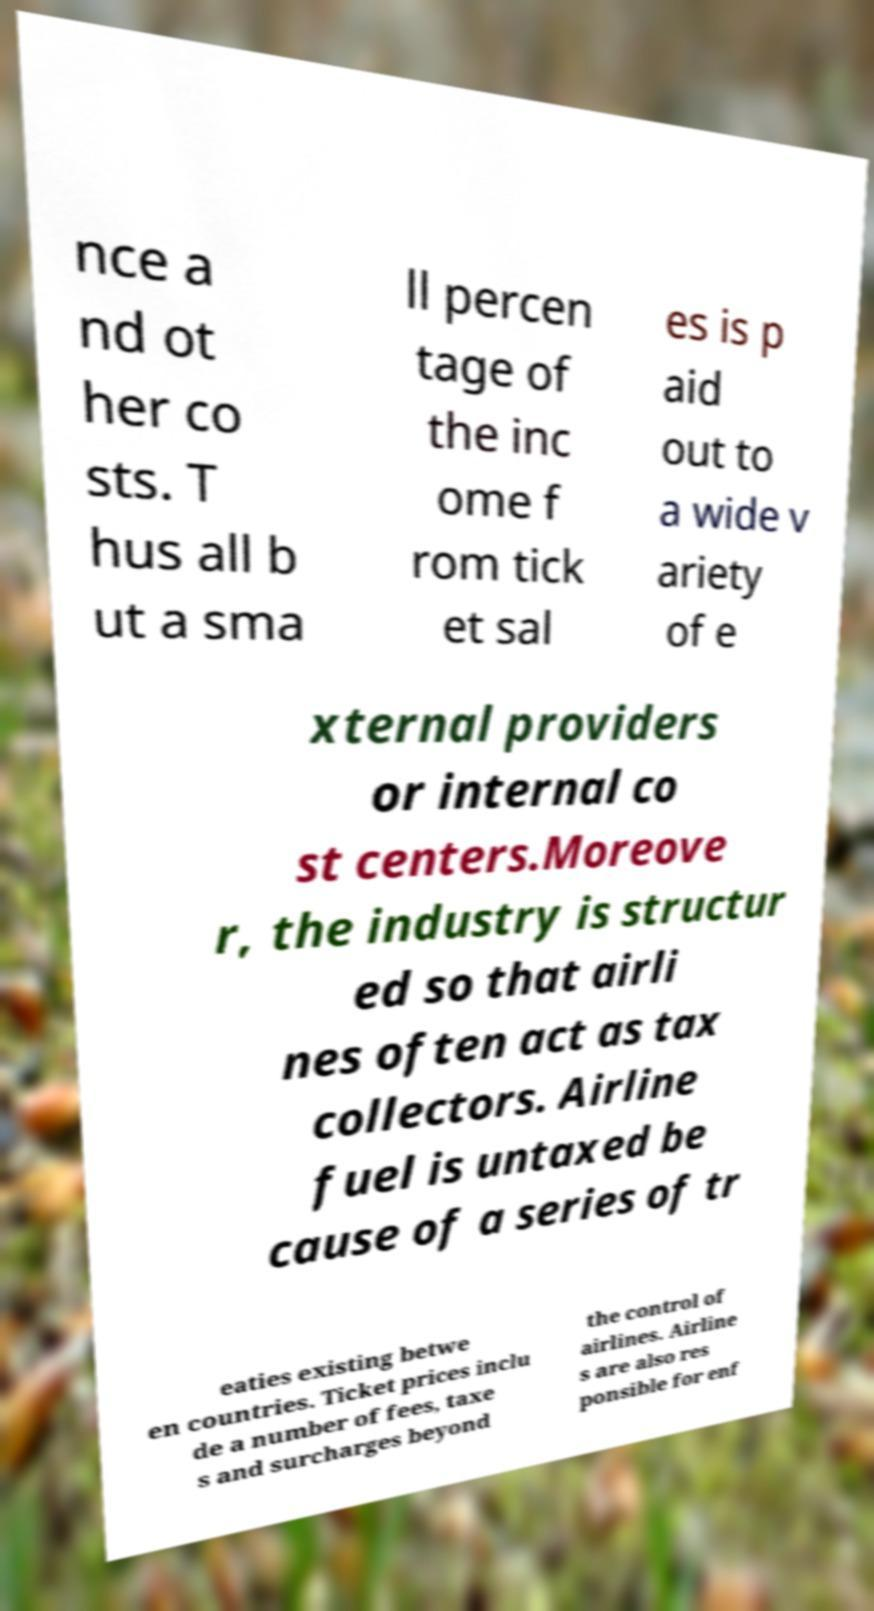For documentation purposes, I need the text within this image transcribed. Could you provide that? nce a nd ot her co sts. T hus all b ut a sma ll percen tage of the inc ome f rom tick et sal es is p aid out to a wide v ariety of e xternal providers or internal co st centers.Moreove r, the industry is structur ed so that airli nes often act as tax collectors. Airline fuel is untaxed be cause of a series of tr eaties existing betwe en countries. Ticket prices inclu de a number of fees, taxe s and surcharges beyond the control of airlines. Airline s are also res ponsible for enf 